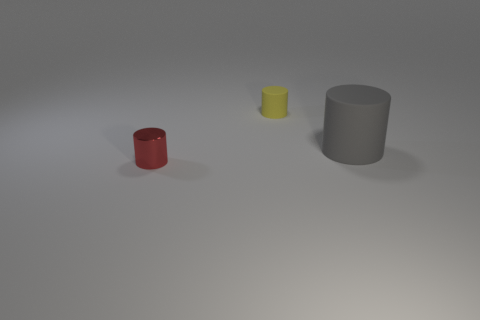How many metal objects are either tiny brown cylinders or small red cylinders? In the image, there is one small red cylinder and no tiny brown cylinders. There's also a small yellow cylinder and a larger grey cylinder, but they do not fit the criteria specified in the question. 